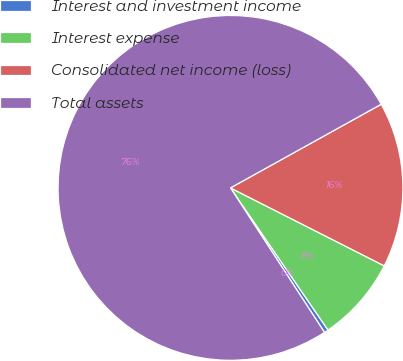<chart> <loc_0><loc_0><loc_500><loc_500><pie_chart><fcel>Interest and investment income<fcel>Interest expense<fcel>Consolidated net income (loss)<fcel>Total assets<nl><fcel>0.39%<fcel>7.96%<fcel>15.53%<fcel>76.12%<nl></chart> 